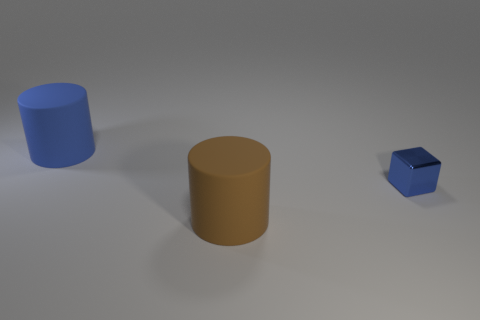Add 1 tiny brown shiny balls. How many objects exist? 4 Subtract 1 cubes. How many cubes are left? 0 Subtract all brown cylinders. How many cylinders are left? 1 Subtract all cylinders. How many objects are left? 1 Add 3 big blue cylinders. How many big blue cylinders exist? 4 Subtract 0 cyan blocks. How many objects are left? 3 Subtract all red blocks. Subtract all red spheres. How many blocks are left? 1 Subtract all purple shiny cubes. Subtract all cylinders. How many objects are left? 1 Add 2 shiny objects. How many shiny objects are left? 3 